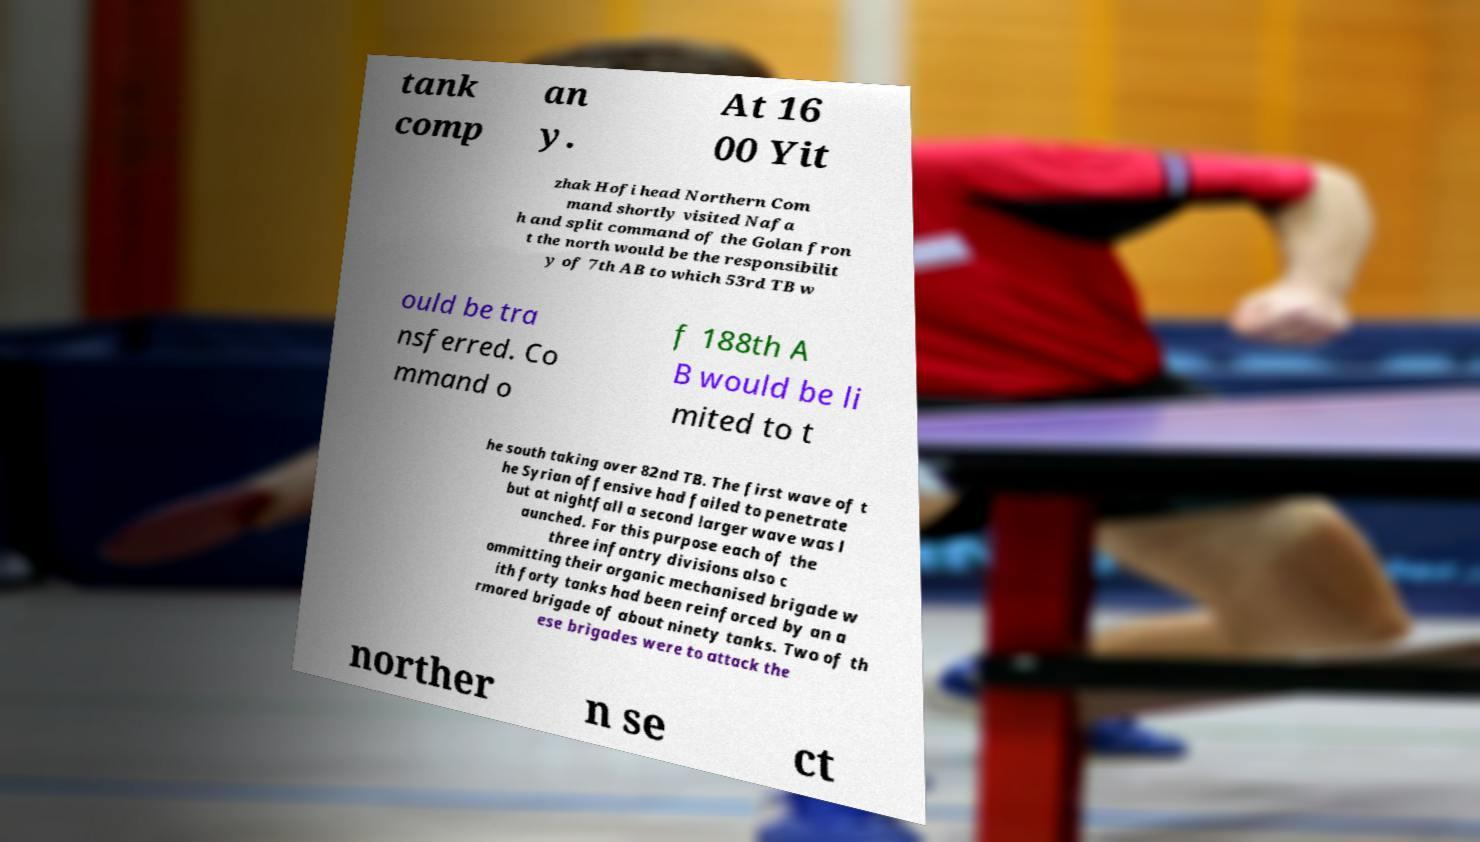Could you assist in decoding the text presented in this image and type it out clearly? tank comp an y. At 16 00 Yit zhak Hofi head Northern Com mand shortly visited Nafa h and split command of the Golan fron t the north would be the responsibilit y of 7th AB to which 53rd TB w ould be tra nsferred. Co mmand o f 188th A B would be li mited to t he south taking over 82nd TB. The first wave of t he Syrian offensive had failed to penetrate but at nightfall a second larger wave was l aunched. For this purpose each of the three infantry divisions also c ommitting their organic mechanised brigade w ith forty tanks had been reinforced by an a rmored brigade of about ninety tanks. Two of th ese brigades were to attack the norther n se ct 